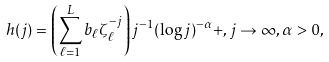Convert formula to latex. <formula><loc_0><loc_0><loc_500><loc_500>h ( j ) = \left ( \sum _ { \ell = 1 } ^ { L } b _ { \ell } \zeta _ { \ell } ^ { - j } \right ) j ^ { - 1 } ( \log j ) ^ { - \alpha } + , j \to \infty , \alpha > 0 ,</formula> 